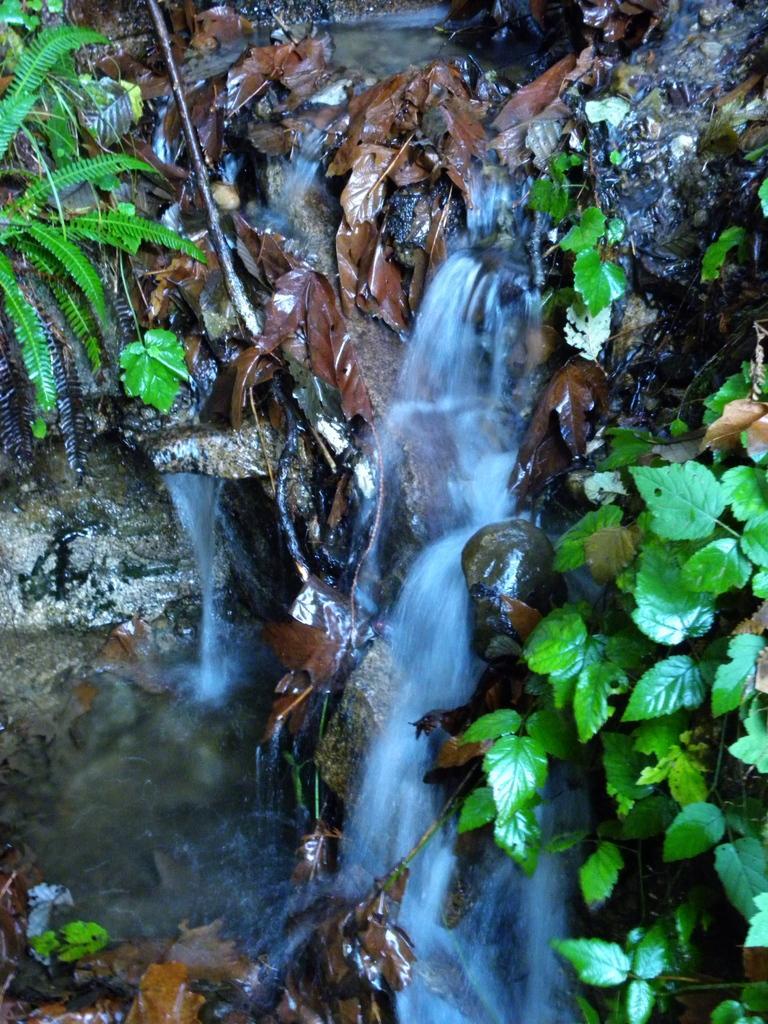Please provide a concise description of this image. This image is taken outdoors. In this image there are a few plants with green leaves and there is a waterfall. 